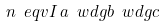<formula> <loc_0><loc_0><loc_500><loc_500>n \ e q v I \, a \ w d g b \ w d g c</formula> 